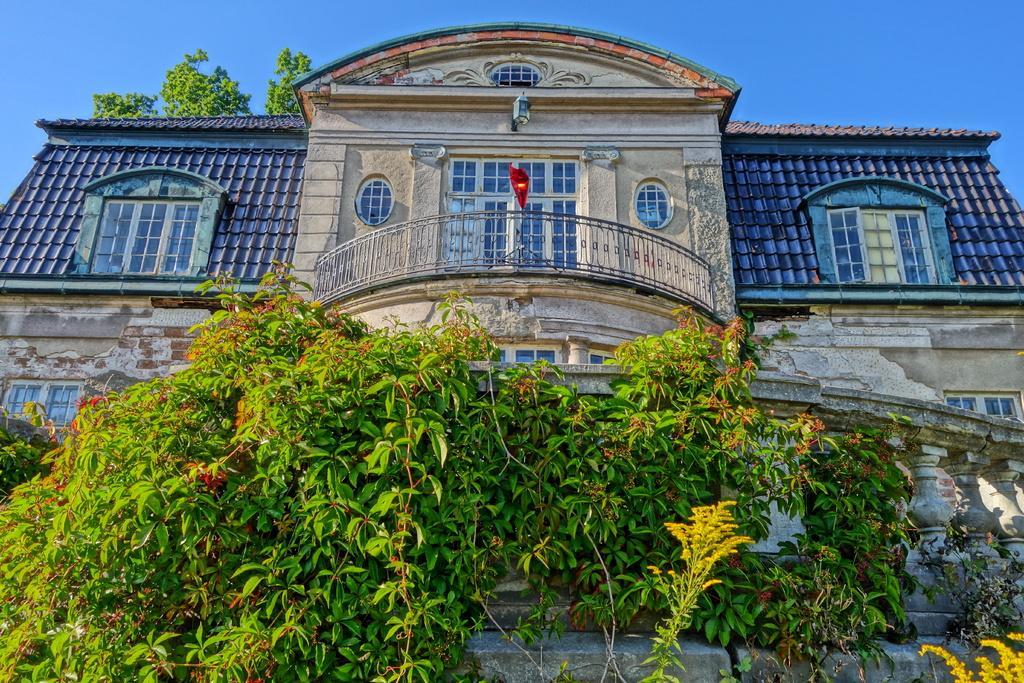Could you give a brief overview of what you see in this image? This picture is taken from outside of the building. In this image, we can see some plants with flowers. In the background, we can see a building, glass window. At the top, we can see a sky and a tree. 